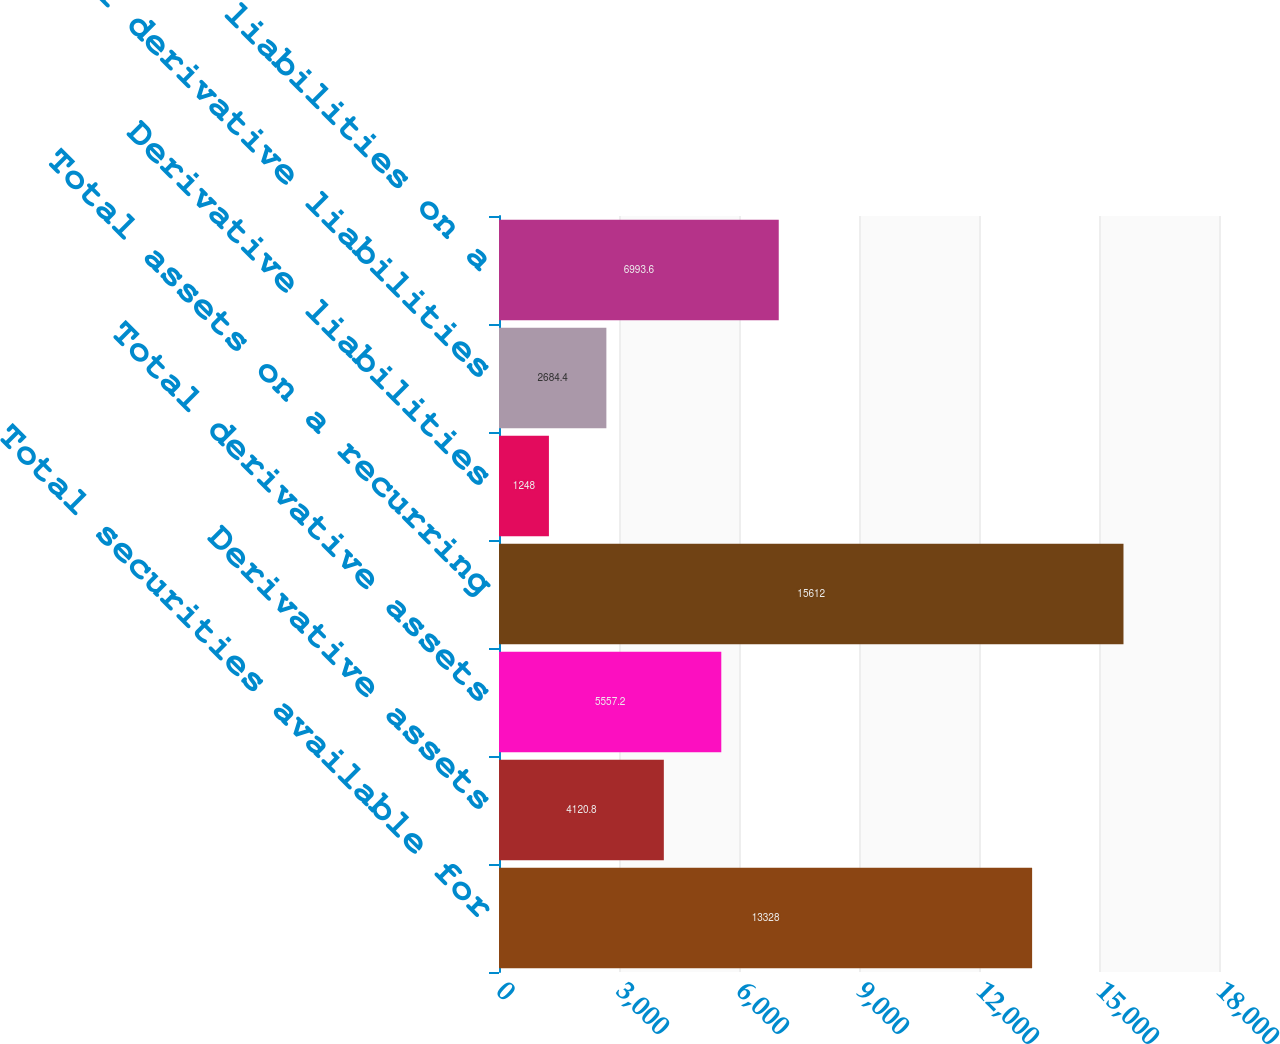<chart> <loc_0><loc_0><loc_500><loc_500><bar_chart><fcel>Total securities available for<fcel>Derivative assets<fcel>Total derivative assets<fcel>Total assets on a recurring<fcel>Derivative liabilities<fcel>Total derivative liabilities<fcel>Total liabilities on a<nl><fcel>13328<fcel>4120.8<fcel>5557.2<fcel>15612<fcel>1248<fcel>2684.4<fcel>6993.6<nl></chart> 